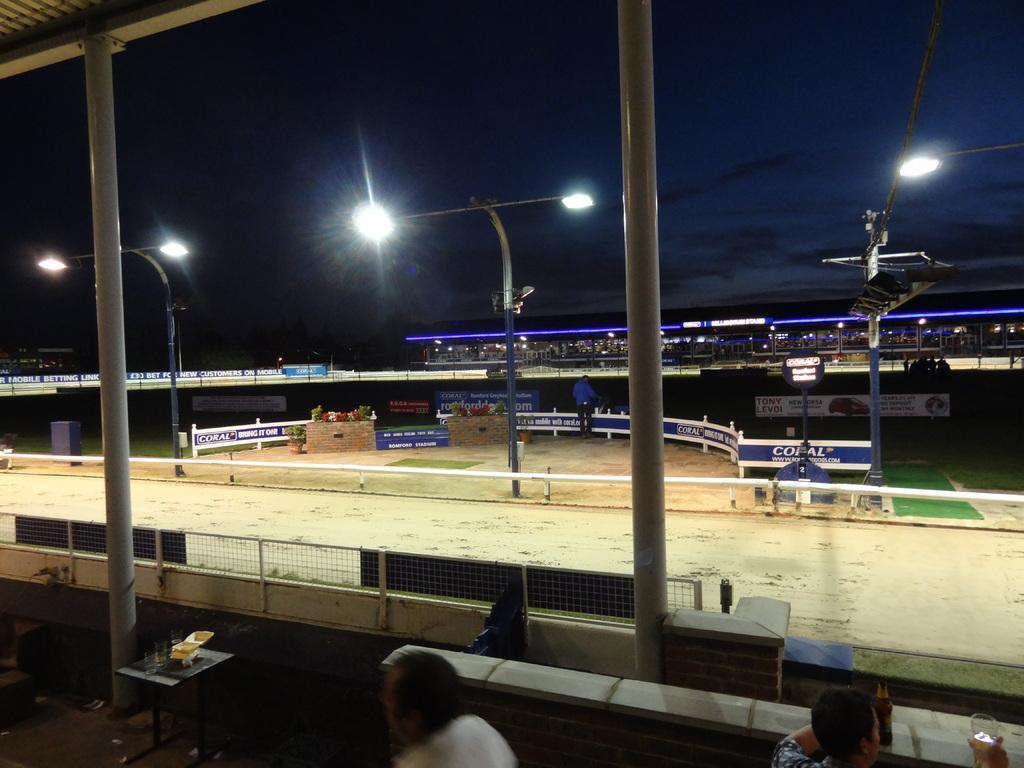In one or two sentences, can you explain what this image depicts? This is an image clicked in the dark. At the bottom of the image I can see two persons and here I can see shed along with the two pillars. In the background there is a building and I can see the ground. This is looking like a stadium. On the ground, I can see few street lights. At the top I can see the sky. 